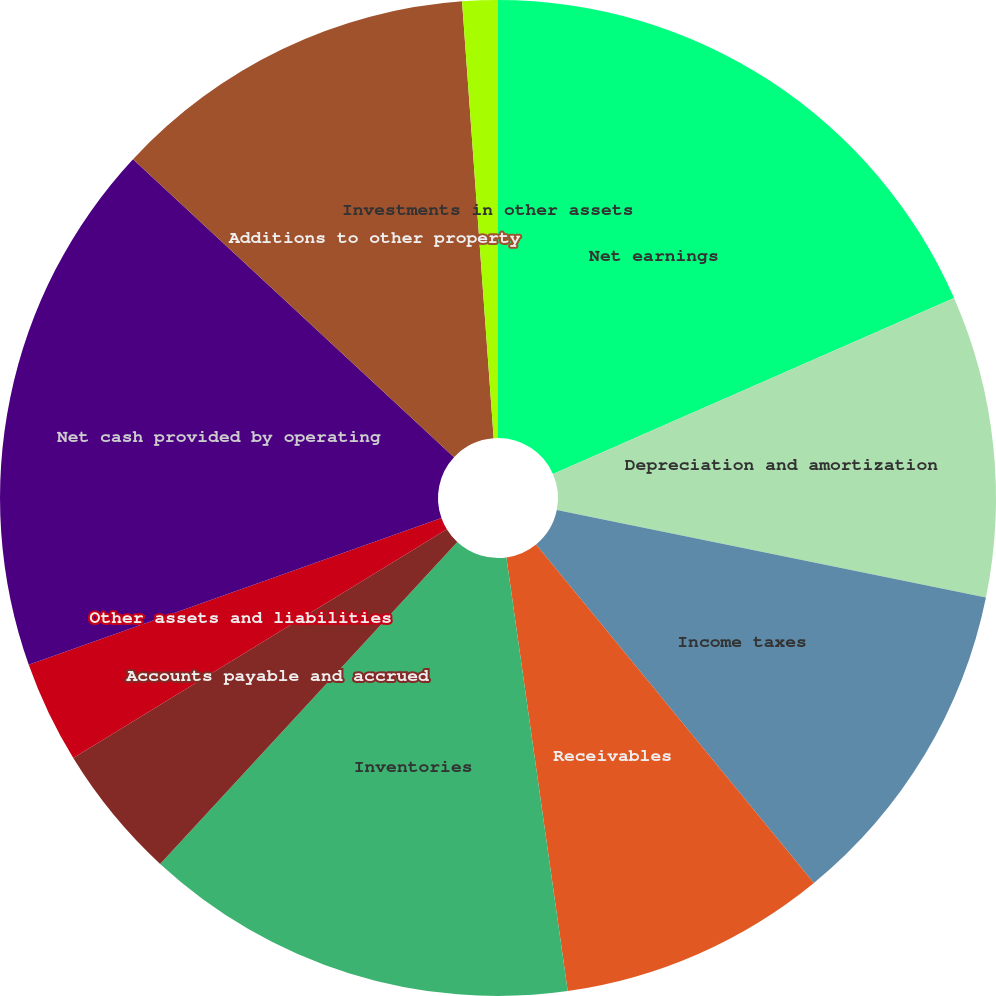Convert chart to OTSL. <chart><loc_0><loc_0><loc_500><loc_500><pie_chart><fcel>Net earnings<fcel>Depreciation and amortization<fcel>Income taxes<fcel>Receivables<fcel>Inventories<fcel>Accounts payable and accrued<fcel>Other assets and liabilities<fcel>Net cash provided by operating<fcel>Additions to other property<fcel>Investments in other assets<nl><fcel>18.42%<fcel>9.78%<fcel>10.86%<fcel>8.7%<fcel>14.1%<fcel>4.39%<fcel>3.31%<fcel>17.34%<fcel>11.94%<fcel>1.15%<nl></chart> 